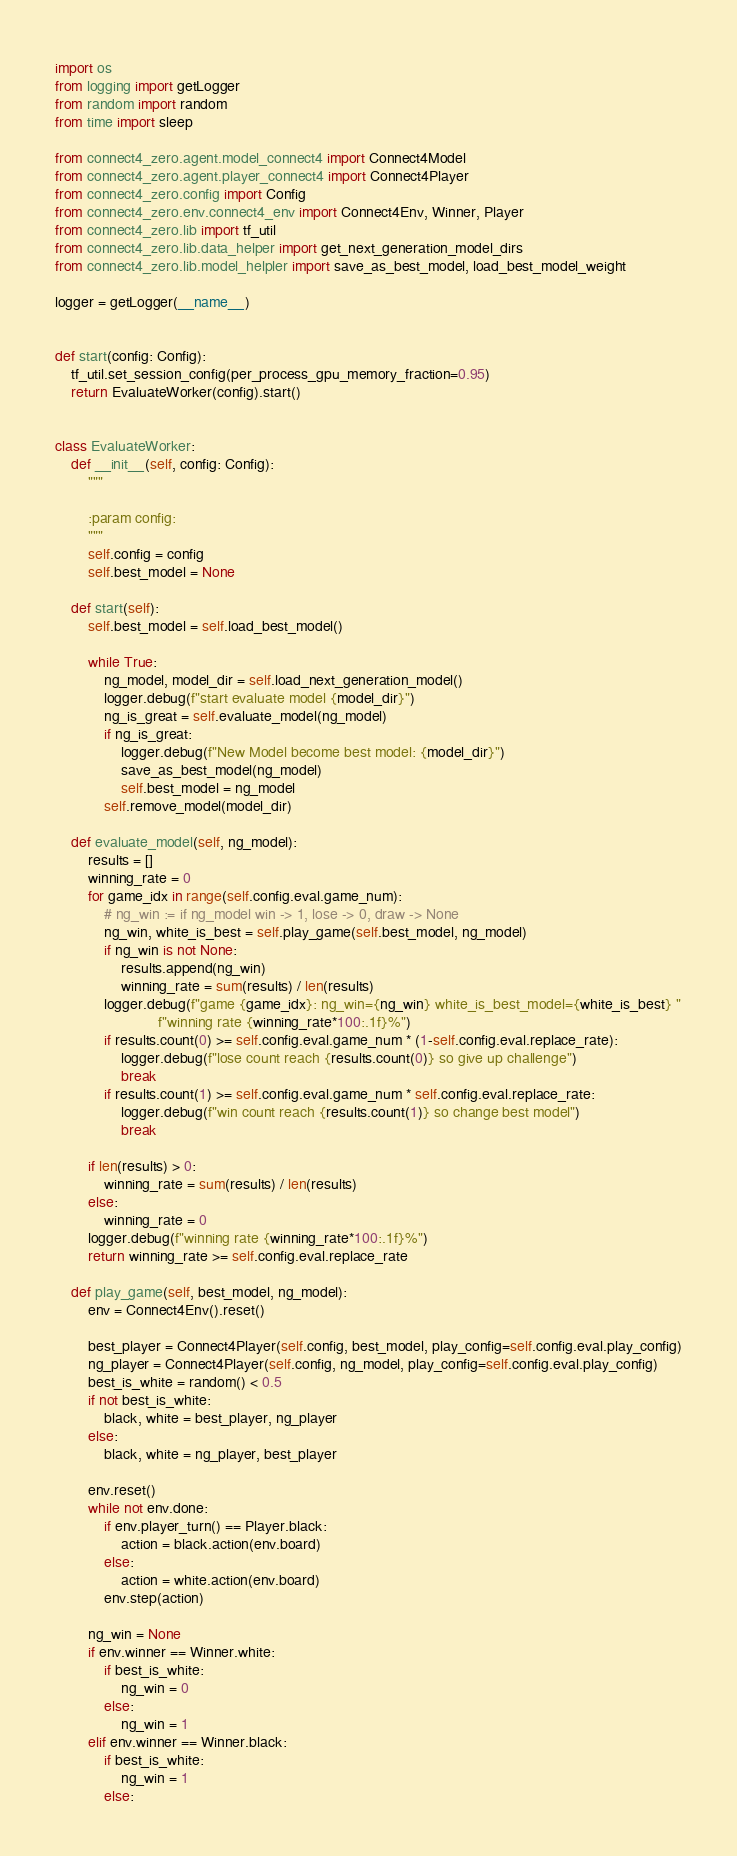<code> <loc_0><loc_0><loc_500><loc_500><_Python_>import os
from logging import getLogger
from random import random
from time import sleep

from connect4_zero.agent.model_connect4 import Connect4Model
from connect4_zero.agent.player_connect4 import Connect4Player
from connect4_zero.config import Config
from connect4_zero.env.connect4_env import Connect4Env, Winner, Player
from connect4_zero.lib import tf_util
from connect4_zero.lib.data_helper import get_next_generation_model_dirs
from connect4_zero.lib.model_helpler import save_as_best_model, load_best_model_weight

logger = getLogger(__name__)


def start(config: Config):
    tf_util.set_session_config(per_process_gpu_memory_fraction=0.95)
    return EvaluateWorker(config).start()


class EvaluateWorker:
    def __init__(self, config: Config):
        """

        :param config:
        """
        self.config = config
        self.best_model = None

    def start(self):
        self.best_model = self.load_best_model()

        while True:
            ng_model, model_dir = self.load_next_generation_model()
            logger.debug(f"start evaluate model {model_dir}")
            ng_is_great = self.evaluate_model(ng_model)
            if ng_is_great:
                logger.debug(f"New Model become best model: {model_dir}")
                save_as_best_model(ng_model)
                self.best_model = ng_model
            self.remove_model(model_dir)

    def evaluate_model(self, ng_model):
        results = []
        winning_rate = 0
        for game_idx in range(self.config.eval.game_num):
            # ng_win := if ng_model win -> 1, lose -> 0, draw -> None
            ng_win, white_is_best = self.play_game(self.best_model, ng_model)
            if ng_win is not None:
                results.append(ng_win)
                winning_rate = sum(results) / len(results)
            logger.debug(f"game {game_idx}: ng_win={ng_win} white_is_best_model={white_is_best} "
                         f"winning rate {winning_rate*100:.1f}%")
            if results.count(0) >= self.config.eval.game_num * (1-self.config.eval.replace_rate):
                logger.debug(f"lose count reach {results.count(0)} so give up challenge")
                break
            if results.count(1) >= self.config.eval.game_num * self.config.eval.replace_rate:
                logger.debug(f"win count reach {results.count(1)} so change best model")
                break

        if len(results) > 0:
            winning_rate = sum(results) / len(results)
        else:
            winning_rate = 0
        logger.debug(f"winning rate {winning_rate*100:.1f}%")
        return winning_rate >= self.config.eval.replace_rate

    def play_game(self, best_model, ng_model):
        env = Connect4Env().reset()

        best_player = Connect4Player(self.config, best_model, play_config=self.config.eval.play_config)
        ng_player = Connect4Player(self.config, ng_model, play_config=self.config.eval.play_config)
        best_is_white = random() < 0.5
        if not best_is_white:
            black, white = best_player, ng_player
        else:
            black, white = ng_player, best_player

        env.reset()
        while not env.done:
            if env.player_turn() == Player.black:
                action = black.action(env.board)
            else:
                action = white.action(env.board)
            env.step(action)

        ng_win = None
        if env.winner == Winner.white:
            if best_is_white:
                ng_win = 0
            else:
                ng_win = 1
        elif env.winner == Winner.black:
            if best_is_white:
                ng_win = 1
            else:</code> 